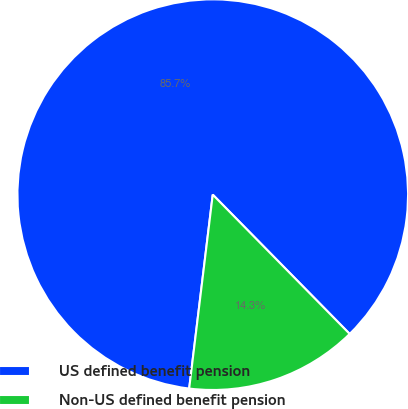<chart> <loc_0><loc_0><loc_500><loc_500><pie_chart><fcel>US defined benefit pension<fcel>Non-US defined benefit pension<nl><fcel>85.71%<fcel>14.29%<nl></chart> 